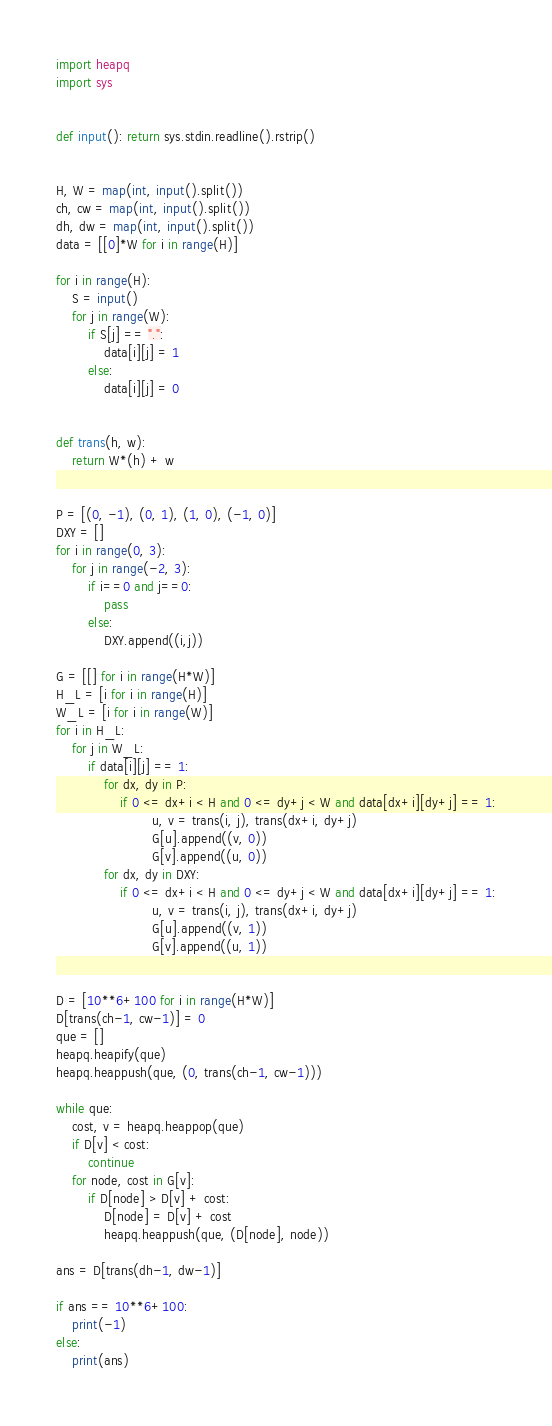<code> <loc_0><loc_0><loc_500><loc_500><_Python_>import heapq
import sys


def input(): return sys.stdin.readline().rstrip()


H, W = map(int, input().split())
ch, cw = map(int, input().split())
dh, dw = map(int, input().split())
data = [[0]*W for i in range(H)]

for i in range(H):
    S = input()
    for j in range(W):
        if S[j] == ".":
            data[i][j] = 1
        else:
            data[i][j] = 0


def trans(h, w):
    return W*(h) + w


P = [(0, -1), (0, 1), (1, 0), (-1, 0)]
DXY = []
for i in range(0, 3):
    for j in range(-2, 3):
        if i==0 and j==0:
            pass
        else:
            DXY.append((i,j))
            
G = [[] for i in range(H*W)]
H_L = [i for i in range(H)]
W_L = [i for i in range(W)]
for i in H_L:
    for j in W_L:
        if data[i][j] == 1:
            for dx, dy in P:
                if 0 <= dx+i < H and 0 <= dy+j < W and data[dx+i][dy+j] == 1:
                        u, v = trans(i, j), trans(dx+i, dy+j)
                        G[u].append((v, 0))
                        G[v].append((u, 0))
            for dx, dy in DXY:
                if 0 <= dx+i < H and 0 <= dy+j < W and data[dx+i][dy+j] == 1:
                        u, v = trans(i, j), trans(dx+i, dy+j)
                        G[u].append((v, 1))
                        G[v].append((u, 1))


D = [10**6+100 for i in range(H*W)]
D[trans(ch-1, cw-1)] = 0
que = []
heapq.heapify(que)
heapq.heappush(que, (0, trans(ch-1, cw-1)))

while que:
    cost, v = heapq.heappop(que)
    if D[v] < cost:
        continue
    for node, cost in G[v]:
        if D[node] > D[v] + cost:
            D[node] = D[v] + cost
            heapq.heappush(que, (D[node], node))

ans = D[trans(dh-1, dw-1)]

if ans == 10**6+100:
    print(-1)
else:
    print(ans)
</code> 